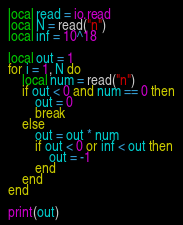<code> <loc_0><loc_0><loc_500><loc_500><_Lua_>local read = io.read
local N = read("n")
local inf = 10^18

local out = 1
for i = 1, N do
	local num = read("n")
	if out < 0 and num == 0 then
		out = 0
		break
	else
		out = out * num
		if out < 0 or inf < out then
			out = -1
		end
	end
end

print(out)
</code> 